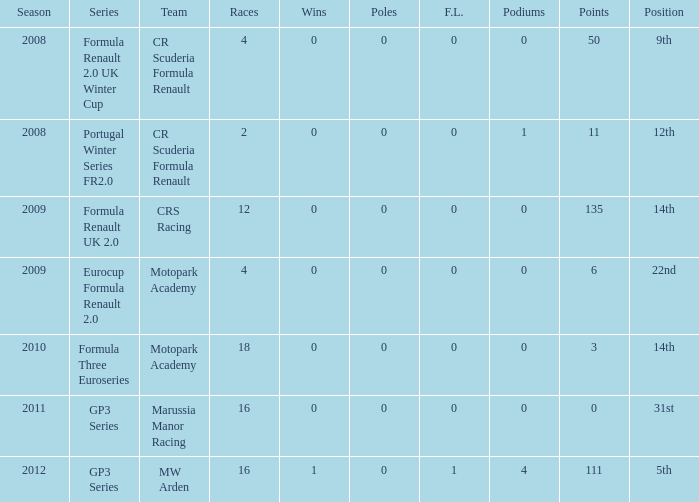In the formula three euroseries, how many f.l. can be found? 1.0. 